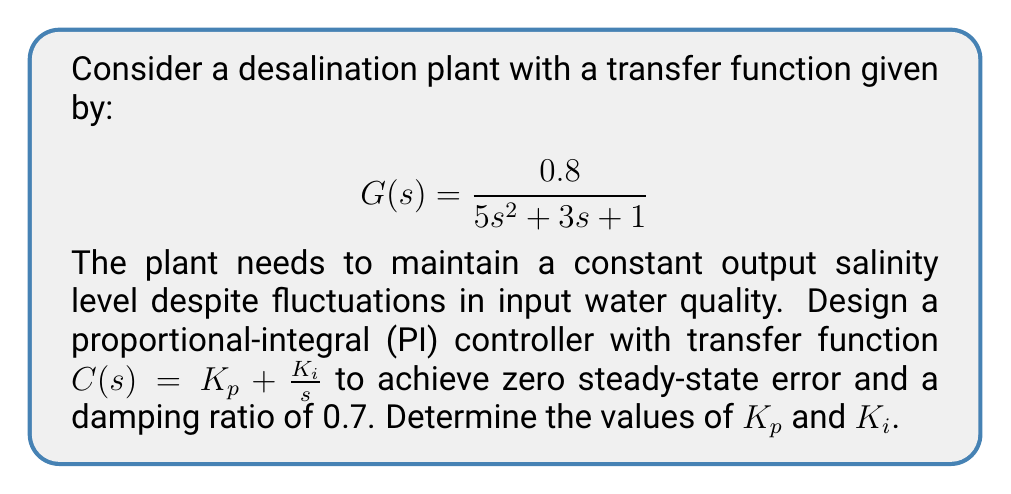Can you answer this question? To design the PI controller, we'll follow these steps:

1) The closed-loop transfer function of the system with the PI controller is:

   $$T(s) = \frac{G(s)C(s)}{1 + G(s)C(s)} = \frac{0.8(K_p s + K_i)}{5s^3 + 3s^2 + s + 0.8K_p s + 0.8K_i}$$

2) The characteristic equation is:

   $$5s^3 + 3s^2 + (1 + 0.8K_p)s + 0.8K_i = 0$$

3) For a second-order dominant response, we can neglect the $s^3$ term. The resulting equation should match the standard form:

   $$s^2 + 2\zeta \omega_n s + \omega_n^2 = 0$$

   Where $\zeta$ is the damping ratio (0.7) and $\omega_n$ is the natural frequency.

4) Comparing coefficients:

   $$3s^2 + (1 + 0.8K_p)s + 0.8K_i = 3(s^2 + 2\zeta \omega_n s + \omega_n^2)$$

5) This gives us two equations:

   $$1 + 0.8K_p = 6\zeta \omega_n = 4.2\omega_n$$
   $$0.8K_i = 3\omega_n^2$$

6) From the first equation:

   $$K_p = \frac{4.2\omega_n - 1}{0.8} = 5.25\omega_n - 1.25$$

7) From the second equation:

   $$K_i = \frac{3\omega_n^2}{0.8} = 3.75\omega_n^2$$

8) To find $\omega_n$, we can use the fact that for a dominant second-order response:

   $$\omega_n = \frac{3}{\zeta} = \frac{3}{0.7} \approx 4.29$$

9) Substituting this value back into the equations for $K_p$ and $K_i$:

   $$K_p = 5.25(4.29) - 1.25 \approx 21.27$$
   $$K_i = 3.75(4.29^2) \approx 68.85$$
Answer: The optimal PI controller parameters are:
$K_p \approx 21.27$ and $K_i \approx 68.85$ 